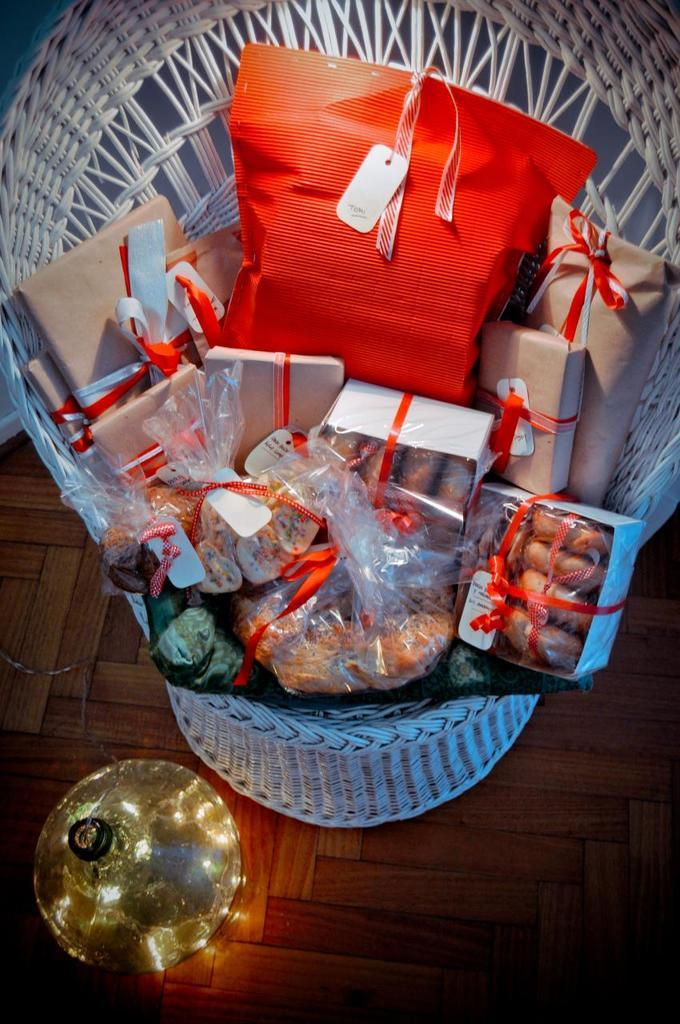What is present in the image that people can sit on? There is a chair in the image that people can sit on. What is on the chair? The chair contains gift covers and boxes. Are there any decorative elements in the image? Yes, there are objects tied with ribbons on the floor or on the chair. What is beside the chair or the objects tied with ribbons? There is a lid beside the chair or the objects tied with ribbons. What type of jam can be seen on the route in the image? There is no jam or route present in the image; it features a chair with gift covers, boxes, and objects tied with ribbons. --- Facts: 1. There is a person in the image. 2. The person is holding a book. 3. The person is sitting on a bench. 4. There is a tree in the background of the image. 5. The person is wearing a hat. Absurd Topics: parrot, sand, bicycle Conversation: Who is present in the image? There is a person in the image. What is the person holding? The person is holding a book. Where is the person sitting? The person is sitting on a bench. What can be seen in the background of the image? There is a tree in the background of the image. What is the person wearing on their head? The person is wearing a hat. Reasoning: Let's think step by step in order to produce the conversation. We start by identifying the main subject in the image, which is the person. Then, we expand the conversation to include the object the person is holding, which is a book. Next, we mention the location of the person, which is on a bench. We then describe the background of the image, which features a tree. Finally, we mention the person's headwear, which is a hat. Absurd Question/Answer: Can you tell me how many parrots are sitting on the sand in the image? There are no parrots or sand present in the image; it features a person holding a book, sitting on a bench, and wearing a hat, with a tree in the background. 